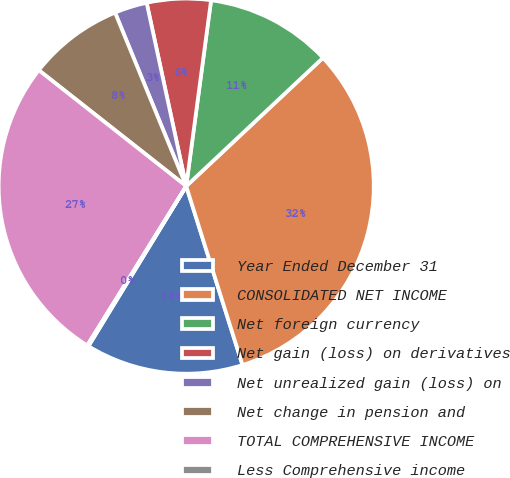Convert chart. <chart><loc_0><loc_0><loc_500><loc_500><pie_chart><fcel>Year Ended December 31<fcel>CONSOLIDATED NET INCOME<fcel>Net foreign currency<fcel>Net gain (loss) on derivatives<fcel>Net unrealized gain (loss) on<fcel>Net change in pension and<fcel>TOTAL COMPREHENSIVE INCOME<fcel>Less Comprehensive income<nl><fcel>13.58%<fcel>32.14%<fcel>10.89%<fcel>5.5%<fcel>2.81%<fcel>8.2%<fcel>26.76%<fcel>0.12%<nl></chart> 